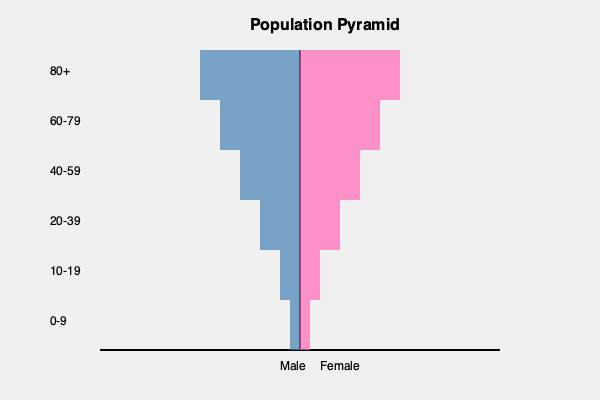Based on the population pyramid shown, which demographic trend is most evident, and what potential sociological implications might this have for the society represented? To interpret this population pyramid and its sociological implications, let's analyze it step-by-step:

1. Shape analysis:
   The pyramid has a broad base that narrows towards the top, resembling a classic pyramid shape.

2. Age distribution:
   - The largest cohorts are in the younger age groups (0-39 years).
   - There's a gradual decrease in population as age increases.
   - The smallest cohort is in the 80+ age group.

3. Demographic trend:
   This shape typically indicates a growing, youthful population with high birth rates and possibly high death rates or low life expectancy.

4. Gender distribution:
   The pyramid appears relatively symmetrical, suggesting no significant gender imbalance.

5. Sociological implications:
   a) High dependency ratio: Large young population relative to working-age adults.
   b) Pressure on education systems to accommodate many young people.
   c) Future challenges in job market as large cohorts enter working age.
   d) Potential for social change and innovation due to large youth population.
   e) Strain on healthcare systems as the population ages over time.
   f) Possible future issues with elder care as smaller older cohorts grow.

6. Traditional research relevance:
   This type of demographic analysis aligns well with traditional sociological research methods, emphasizing population studies and their societal impacts.

The most evident trend is a growing, youthful population, which has significant implications for social structures, resource allocation, and future planning in areas such as education, employment, and healthcare.
Answer: Growing, youthful population with high birth rates, implying increased pressure on education and future job markets. 